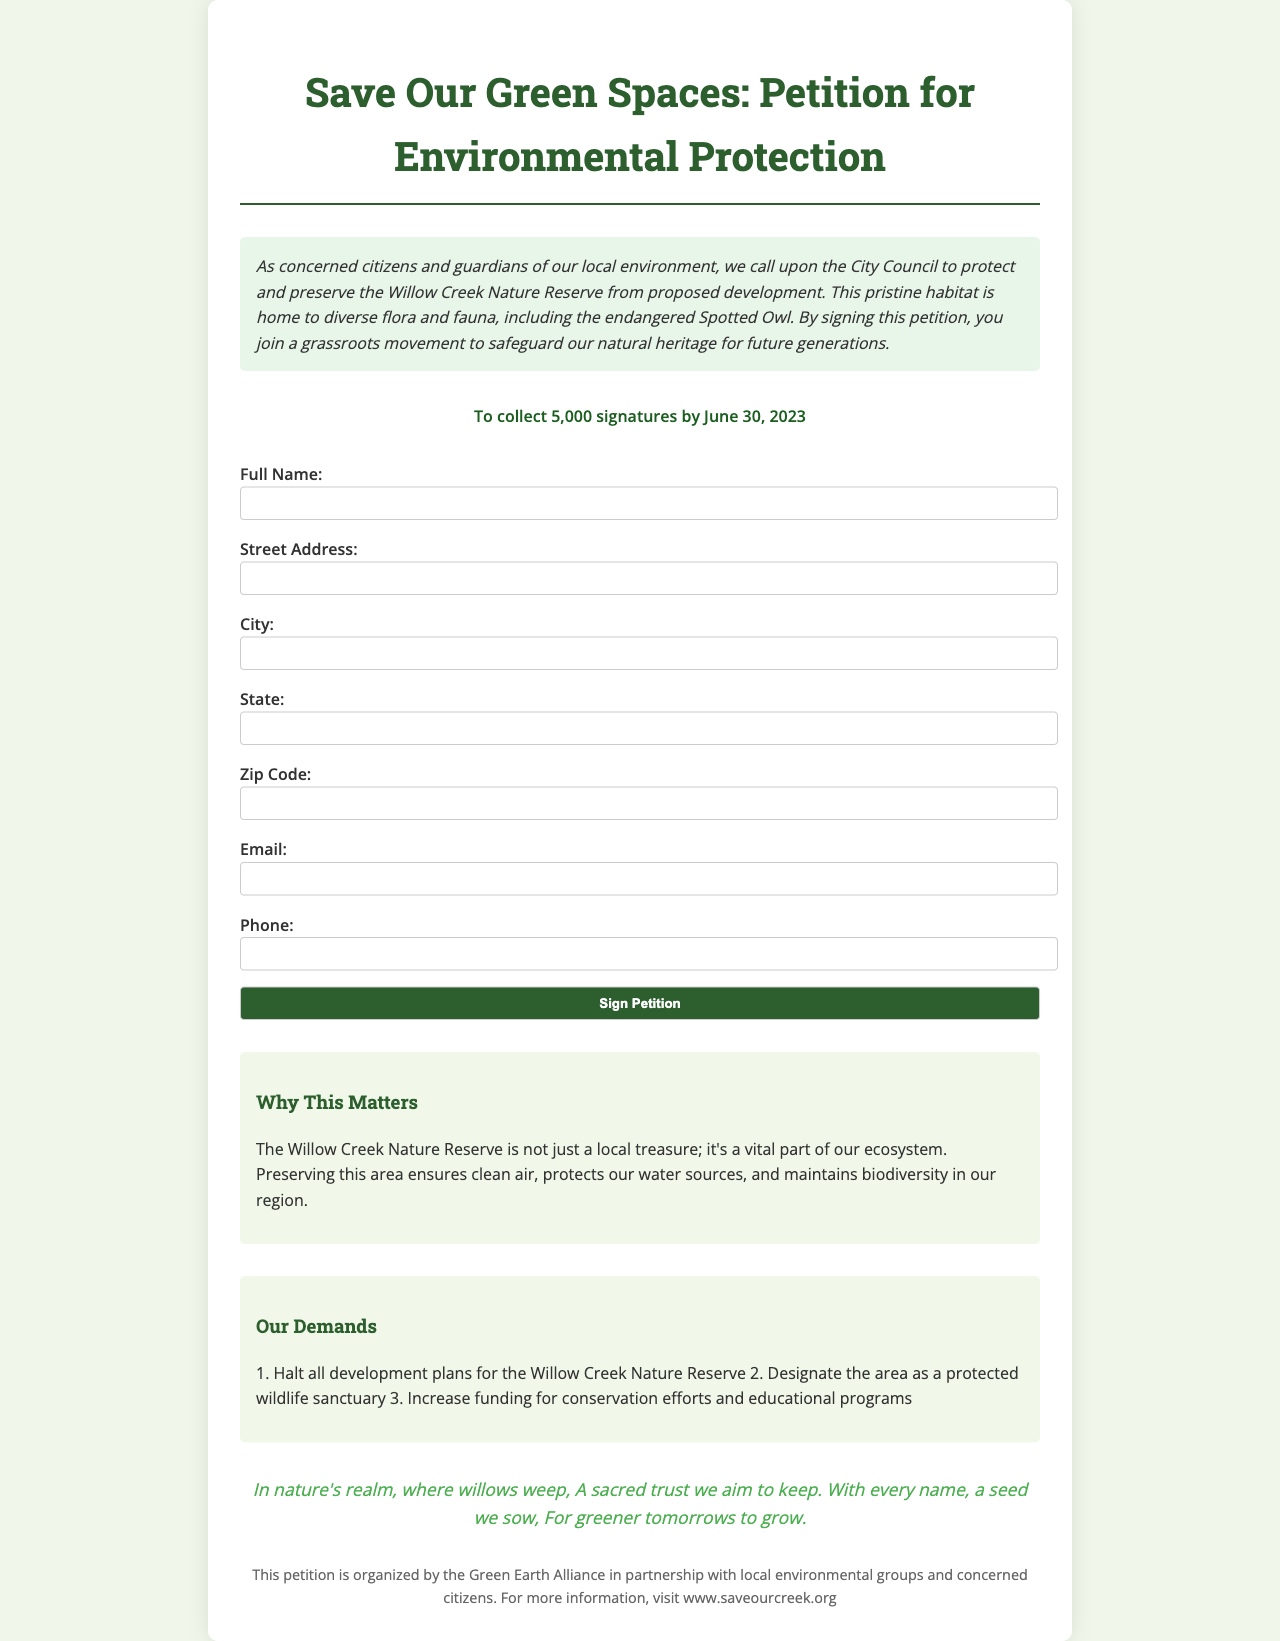What is the title of the petition? The title of the petition is explicitly stated at the top of the document.
Answer: Save Our Green Spaces: Petition for Environmental Protection What is the deadline for collecting signatures? The deadline for signature collection is mentioned in the petition goal section.
Answer: June 30, 2023 How many signatures does the petition aim to collect? The number of signatures required is clearly specified in the petition goal section.
Answer: 5,000 What is one of the demands mentioned in the petition? The demands listed in the document highlight specific actions requested regarding environmental protection.
Answer: Halt all development plans for the Willow Creek Nature Reserve Which endangered species is mentioned in the introduction? The introduction specifies the endangered species that inhabits the area of concern.
Answer: Spotted Owl What is the purpose of the email field in the form? The email field in the form is optional and intended for communication purposes.
Answer: Communication What organization is organizing the petition? The footer of the document states the name of the organization responsible for the petition.
Answer: Green Earth Alliance What is the significance of preserving the Willow Creek Nature Reserve? The additional info section describes the ecological importance of maintaining the area.
Answer: Ensures clean air What poetic inspiration is included in the document? The document contains a section that includes a poetic expression reflecting the cause of the petition.
Answer: In nature's realm, where willows weep, A sacred trust we aim to keep 